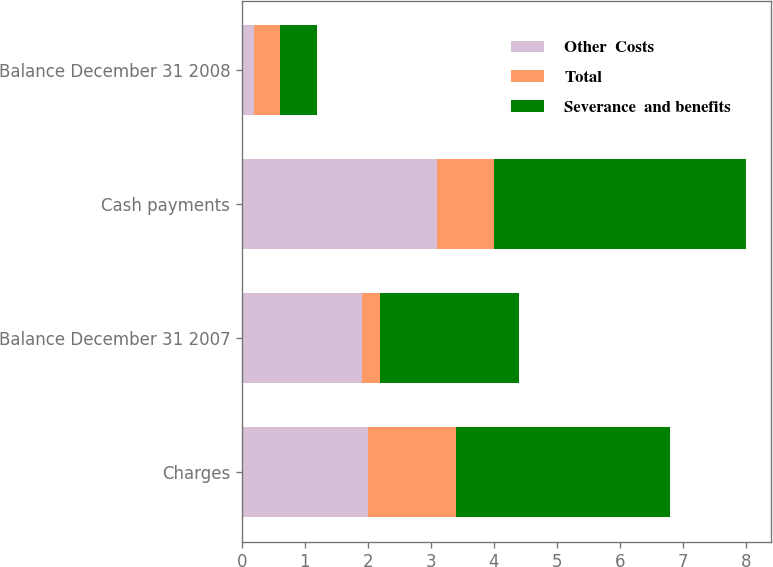<chart> <loc_0><loc_0><loc_500><loc_500><stacked_bar_chart><ecel><fcel>Charges<fcel>Balance December 31 2007<fcel>Cash payments<fcel>Balance December 31 2008<nl><fcel>Other  Costs<fcel>2<fcel>1.9<fcel>3.1<fcel>0.2<nl><fcel>Total<fcel>1.4<fcel>0.3<fcel>0.9<fcel>0.4<nl><fcel>Severance  and benefits<fcel>3.4<fcel>2.2<fcel>4<fcel>0.6<nl></chart> 